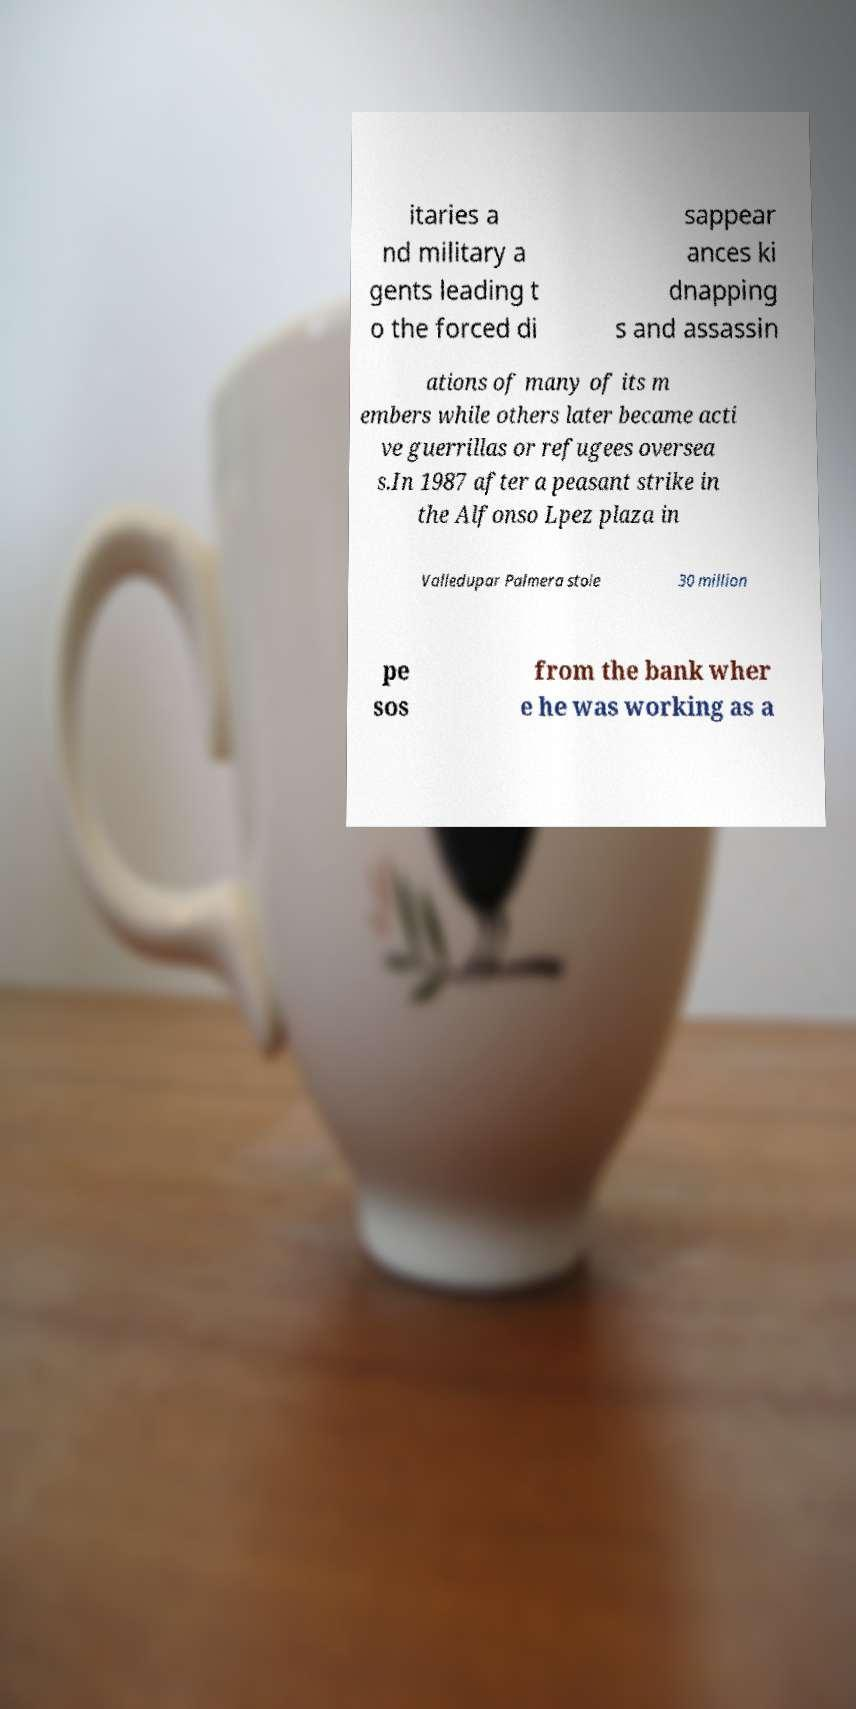Could you assist in decoding the text presented in this image and type it out clearly? itaries a nd military a gents leading t o the forced di sappear ances ki dnapping s and assassin ations of many of its m embers while others later became acti ve guerrillas or refugees oversea s.In 1987 after a peasant strike in the Alfonso Lpez plaza in Valledupar Palmera stole 30 million pe sos from the bank wher e he was working as a 